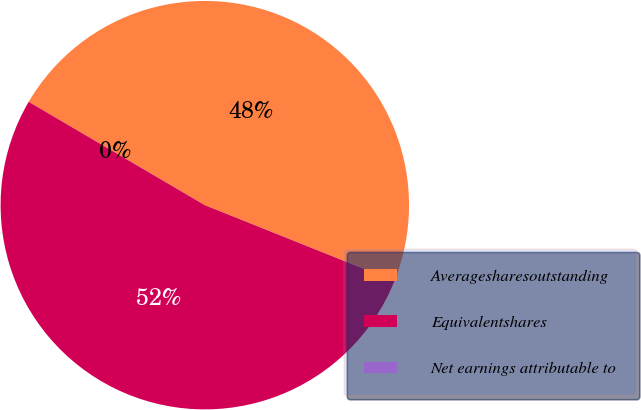Convert chart. <chart><loc_0><loc_0><loc_500><loc_500><pie_chart><fcel>Averagesharesoutstanding<fcel>Equivalentshares<fcel>Net earnings attributable to<nl><fcel>47.62%<fcel>52.38%<fcel>0.0%<nl></chart> 